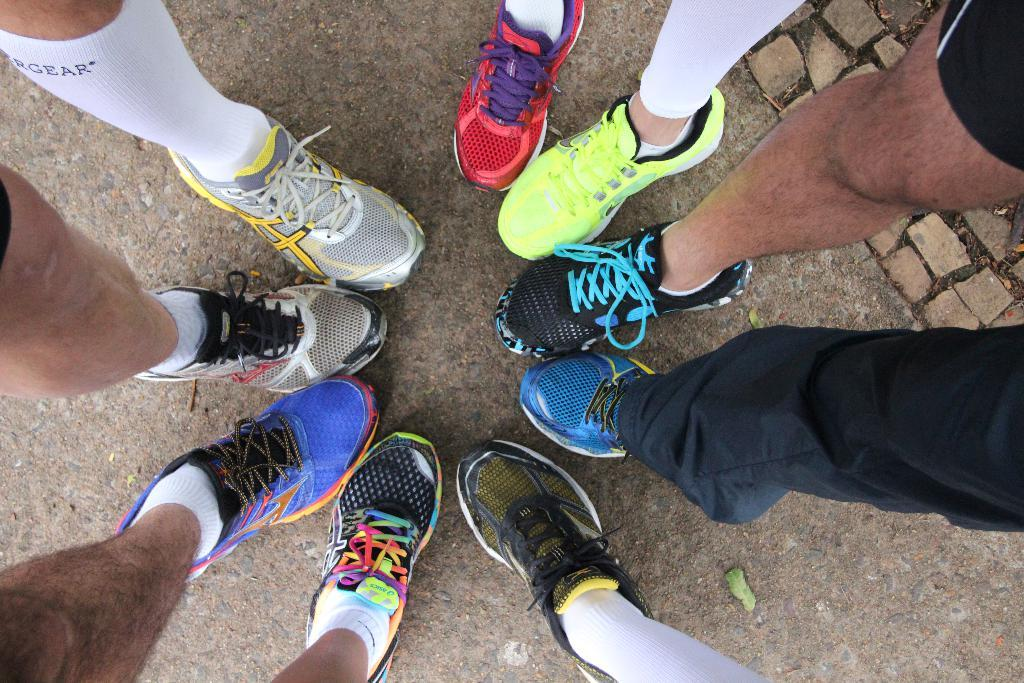How many persons are in the image? There are multiple persons in the image. What can be observed about the footwear of the persons? The persons are wearing different colored shoes. What else can be seen on the feet of the persons? The persons are wearing different colored socks. What part of the persons' bodies is the main focus of the image? The focus of the image is on the legs of the persons. What is the woman's fear of in the image? There is no woman present in the image, and therefore no fear can be observed. 